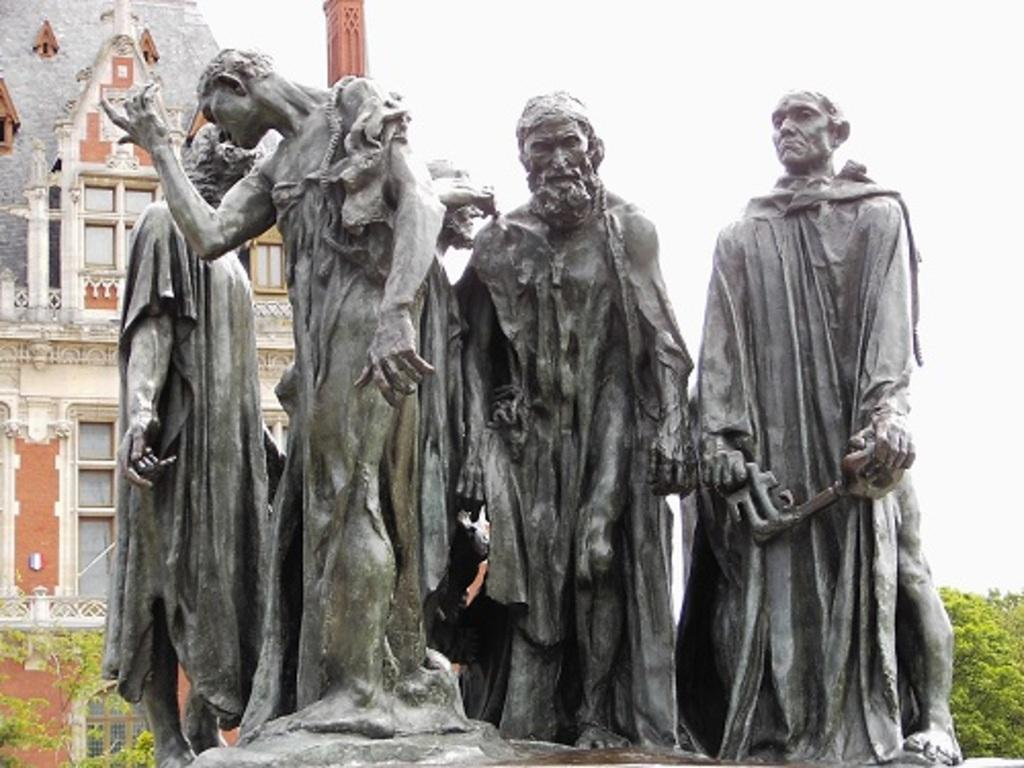What is the main subject of the image? The main subject of the image is a statue of people. What other structures or objects can be seen in the image? There is a building in the image. What features can be observed on the building? The building has windows. What type of natural elements are present in the image? There are trees in the image. What is visible in the background of the image? The sky is visible in the image. What type of alarm can be heard going off in the image? There is no alarm present in the image, and therefore no sound can be heard. 